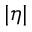<formula> <loc_0><loc_0><loc_500><loc_500>| \eta |</formula> 